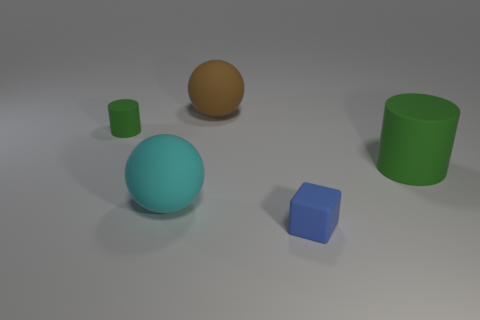How many big objects are blue objects or cyan matte objects?
Your answer should be very brief. 1. How many things are objects that are in front of the small cylinder or green objects left of the large green matte cylinder?
Your answer should be very brief. 4. Is the number of large brown matte objects less than the number of matte things?
Provide a succinct answer. Yes. There is a green matte object that is the same size as the blue object; what shape is it?
Your answer should be compact. Cylinder. What number of other things are there of the same color as the large cylinder?
Keep it short and to the point. 1. How many small matte cylinders are there?
Ensure brevity in your answer.  1. What number of green matte things are both on the right side of the cyan matte thing and to the left of the brown rubber ball?
Your answer should be very brief. 0. What is the cube made of?
Make the answer very short. Rubber. Is there a green cylinder?
Your answer should be very brief. Yes. There is a cylinder that is on the left side of the blue block; what is its color?
Your response must be concise. Green. 